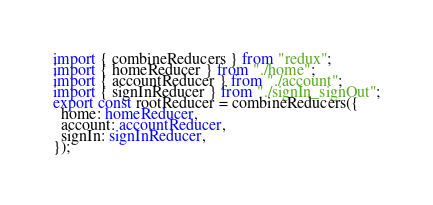<code> <loc_0><loc_0><loc_500><loc_500><_TypeScript_>import { combineReducers } from "redux";
import { homeReducer } from "./home";
import { accountReducer } from "./account";
import { signInReducer } from "./signIn_signOut";
export const rootReducer = combineReducers({
  home: homeReducer,
  account: accountReducer,
  signIn: signInReducer,
});
</code> 